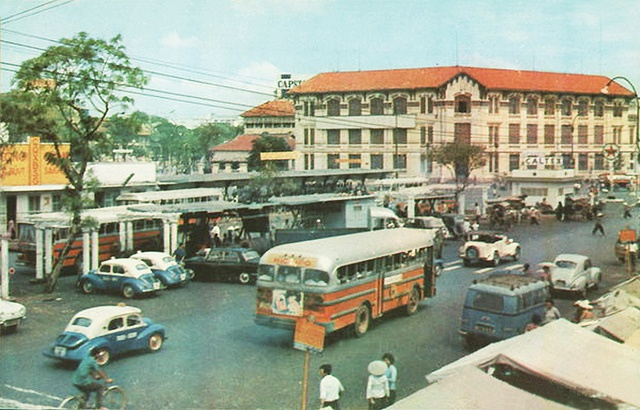Describe the objects in this image and their specific colors. I can see bus in lightblue, beige, gray, and darkgray tones, car in lightblue, beige, and teal tones, car in lightblue, gray, darkgray, and black tones, bus in lightblue, gray, and black tones, and car in lightblue, beige, teal, and black tones in this image. 